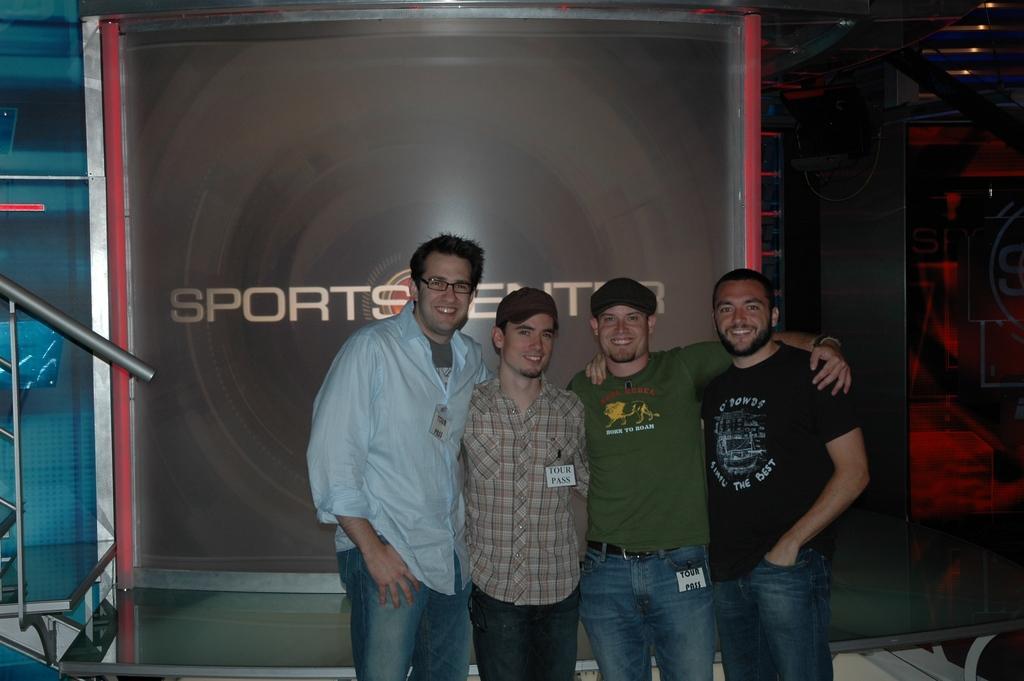Can you describe this image briefly? In the center of the image there are four persons standing. In the background of the image there is some banner with text. To the left side of the image there is a railing. 